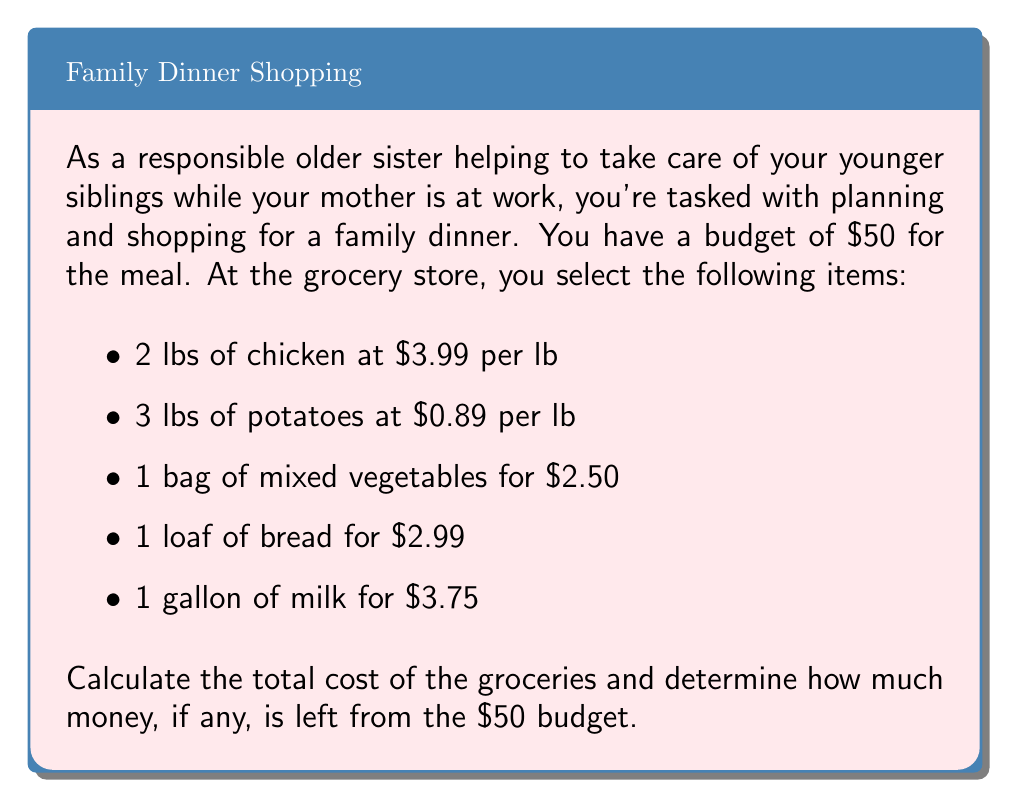Can you solve this math problem? To solve this problem, we need to follow these steps:

1. Calculate the cost of chicken:
   $2 \text{ lbs} \times \$3.99/\text{lb} = \$7.98$

2. Calculate the cost of potatoes:
   $3 \text{ lbs} \times \$0.89/\text{lb} = \$2.67$

3. Add up the costs of all items:
   $$\begin{align*}
   \text{Total} &= \text{Chicken} + \text{Potatoes} + \text{Vegetables} + \text{Bread} + \text{Milk} \\
   &= \$7.98 + \$2.67 + \$2.50 + \$2.99 + \$3.75 \\
   &= \$19.89
   \end{align*}$$

4. Calculate the remaining budget:
   $$\begin{align*}
   \text{Remaining} &= \text{Budget} - \text{Total spent} \\
   &= \$50.00 - \$19.89 \\
   &= \$30.11
   \end{align*}$$

Therefore, the total cost of groceries is $19.89, and there is $30.11 left from the $50 budget.
Answer: The total cost of groceries is $19.89, and $30.11 is left from the $50 budget. 